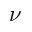<formula> <loc_0><loc_0><loc_500><loc_500>\nu</formula> 